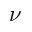<formula> <loc_0><loc_0><loc_500><loc_500>\nu</formula> 